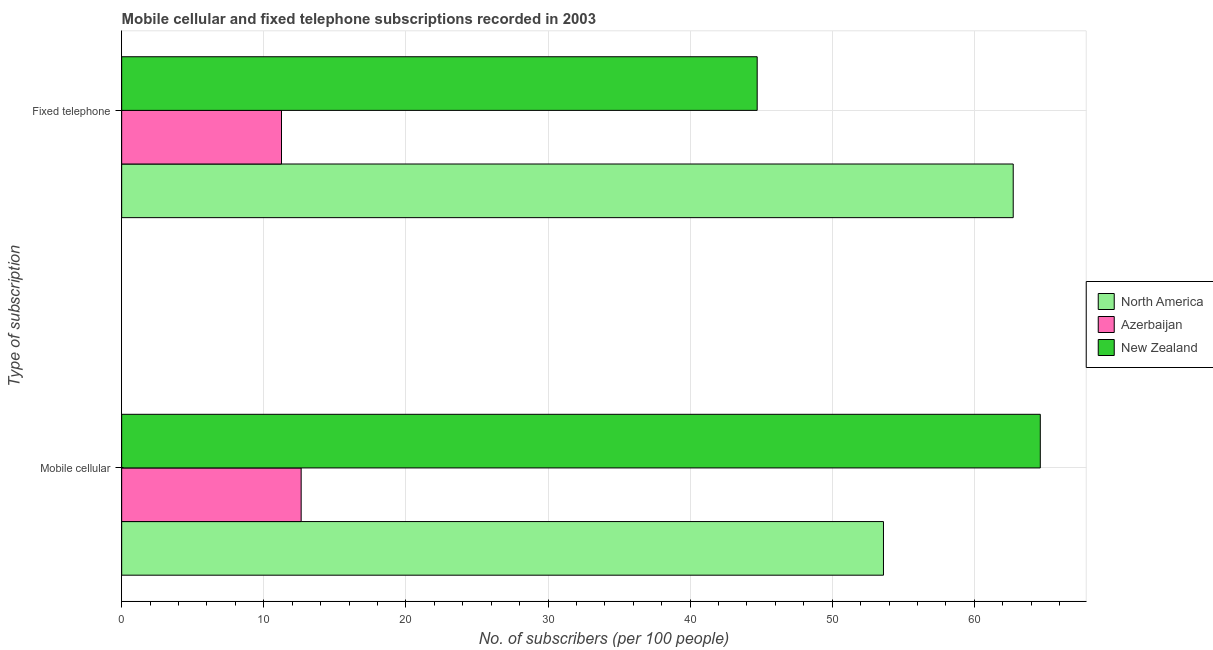How many groups of bars are there?
Your response must be concise. 2. Are the number of bars per tick equal to the number of legend labels?
Provide a succinct answer. Yes. How many bars are there on the 1st tick from the top?
Keep it short and to the point. 3. How many bars are there on the 1st tick from the bottom?
Make the answer very short. 3. What is the label of the 1st group of bars from the top?
Ensure brevity in your answer.  Fixed telephone. What is the number of fixed telephone subscribers in Azerbaijan?
Provide a succinct answer. 11.25. Across all countries, what is the maximum number of fixed telephone subscribers?
Offer a very short reply. 62.74. Across all countries, what is the minimum number of fixed telephone subscribers?
Offer a very short reply. 11.25. In which country was the number of mobile cellular subscribers maximum?
Your answer should be very brief. New Zealand. In which country was the number of fixed telephone subscribers minimum?
Your response must be concise. Azerbaijan. What is the total number of fixed telephone subscribers in the graph?
Provide a short and direct response. 118.7. What is the difference between the number of fixed telephone subscribers in North America and that in New Zealand?
Your answer should be very brief. 18.02. What is the difference between the number of mobile cellular subscribers in New Zealand and the number of fixed telephone subscribers in North America?
Keep it short and to the point. 1.91. What is the average number of fixed telephone subscribers per country?
Your response must be concise. 39.57. What is the difference between the number of fixed telephone subscribers and number of mobile cellular subscribers in North America?
Your answer should be very brief. 9.13. In how many countries, is the number of mobile cellular subscribers greater than 20 ?
Your answer should be compact. 2. What is the ratio of the number of mobile cellular subscribers in North America to that in New Zealand?
Keep it short and to the point. 0.83. Is the number of mobile cellular subscribers in New Zealand less than that in Azerbaijan?
Your answer should be very brief. No. What does the 3rd bar from the bottom in Fixed telephone represents?
Keep it short and to the point. New Zealand. Are all the bars in the graph horizontal?
Your answer should be compact. Yes. Are the values on the major ticks of X-axis written in scientific E-notation?
Make the answer very short. No. Does the graph contain any zero values?
Provide a short and direct response. No. Does the graph contain grids?
Your answer should be very brief. Yes. Where does the legend appear in the graph?
Your answer should be very brief. Center right. How are the legend labels stacked?
Provide a succinct answer. Vertical. What is the title of the graph?
Your response must be concise. Mobile cellular and fixed telephone subscriptions recorded in 2003. What is the label or title of the X-axis?
Your answer should be very brief. No. of subscribers (per 100 people). What is the label or title of the Y-axis?
Offer a very short reply. Type of subscription. What is the No. of subscribers (per 100 people) in North America in Mobile cellular?
Your response must be concise. 53.6. What is the No. of subscribers (per 100 people) of Azerbaijan in Mobile cellular?
Your answer should be very brief. 12.63. What is the No. of subscribers (per 100 people) of New Zealand in Mobile cellular?
Make the answer very short. 64.64. What is the No. of subscribers (per 100 people) in North America in Fixed telephone?
Offer a terse response. 62.74. What is the No. of subscribers (per 100 people) in Azerbaijan in Fixed telephone?
Offer a terse response. 11.25. What is the No. of subscribers (per 100 people) of New Zealand in Fixed telephone?
Provide a short and direct response. 44.72. Across all Type of subscription, what is the maximum No. of subscribers (per 100 people) in North America?
Keep it short and to the point. 62.74. Across all Type of subscription, what is the maximum No. of subscribers (per 100 people) in Azerbaijan?
Your answer should be compact. 12.63. Across all Type of subscription, what is the maximum No. of subscribers (per 100 people) of New Zealand?
Give a very brief answer. 64.64. Across all Type of subscription, what is the minimum No. of subscribers (per 100 people) in North America?
Provide a short and direct response. 53.6. Across all Type of subscription, what is the minimum No. of subscribers (per 100 people) of Azerbaijan?
Offer a very short reply. 11.25. Across all Type of subscription, what is the minimum No. of subscribers (per 100 people) in New Zealand?
Your answer should be compact. 44.72. What is the total No. of subscribers (per 100 people) of North America in the graph?
Make the answer very short. 116.34. What is the total No. of subscribers (per 100 people) of Azerbaijan in the graph?
Make the answer very short. 23.88. What is the total No. of subscribers (per 100 people) of New Zealand in the graph?
Provide a succinct answer. 109.36. What is the difference between the No. of subscribers (per 100 people) of North America in Mobile cellular and that in Fixed telephone?
Make the answer very short. -9.13. What is the difference between the No. of subscribers (per 100 people) in Azerbaijan in Mobile cellular and that in Fixed telephone?
Ensure brevity in your answer.  1.38. What is the difference between the No. of subscribers (per 100 people) in New Zealand in Mobile cellular and that in Fixed telephone?
Your answer should be compact. 19.92. What is the difference between the No. of subscribers (per 100 people) in North America in Mobile cellular and the No. of subscribers (per 100 people) in Azerbaijan in Fixed telephone?
Ensure brevity in your answer.  42.36. What is the difference between the No. of subscribers (per 100 people) in North America in Mobile cellular and the No. of subscribers (per 100 people) in New Zealand in Fixed telephone?
Make the answer very short. 8.89. What is the difference between the No. of subscribers (per 100 people) of Azerbaijan in Mobile cellular and the No. of subscribers (per 100 people) of New Zealand in Fixed telephone?
Your response must be concise. -32.09. What is the average No. of subscribers (per 100 people) of North America per Type of subscription?
Your response must be concise. 58.17. What is the average No. of subscribers (per 100 people) of Azerbaijan per Type of subscription?
Offer a terse response. 11.94. What is the average No. of subscribers (per 100 people) of New Zealand per Type of subscription?
Your answer should be very brief. 54.68. What is the difference between the No. of subscribers (per 100 people) of North America and No. of subscribers (per 100 people) of Azerbaijan in Mobile cellular?
Offer a very short reply. 40.98. What is the difference between the No. of subscribers (per 100 people) of North America and No. of subscribers (per 100 people) of New Zealand in Mobile cellular?
Your answer should be compact. -11.04. What is the difference between the No. of subscribers (per 100 people) in Azerbaijan and No. of subscribers (per 100 people) in New Zealand in Mobile cellular?
Make the answer very short. -52.01. What is the difference between the No. of subscribers (per 100 people) of North America and No. of subscribers (per 100 people) of Azerbaijan in Fixed telephone?
Provide a succinct answer. 51.49. What is the difference between the No. of subscribers (per 100 people) of North America and No. of subscribers (per 100 people) of New Zealand in Fixed telephone?
Provide a succinct answer. 18.02. What is the difference between the No. of subscribers (per 100 people) of Azerbaijan and No. of subscribers (per 100 people) of New Zealand in Fixed telephone?
Your response must be concise. -33.47. What is the ratio of the No. of subscribers (per 100 people) in North America in Mobile cellular to that in Fixed telephone?
Make the answer very short. 0.85. What is the ratio of the No. of subscribers (per 100 people) in Azerbaijan in Mobile cellular to that in Fixed telephone?
Provide a succinct answer. 1.12. What is the ratio of the No. of subscribers (per 100 people) in New Zealand in Mobile cellular to that in Fixed telephone?
Provide a succinct answer. 1.45. What is the difference between the highest and the second highest No. of subscribers (per 100 people) of North America?
Your answer should be very brief. 9.13. What is the difference between the highest and the second highest No. of subscribers (per 100 people) in Azerbaijan?
Offer a terse response. 1.38. What is the difference between the highest and the second highest No. of subscribers (per 100 people) in New Zealand?
Offer a terse response. 19.92. What is the difference between the highest and the lowest No. of subscribers (per 100 people) of North America?
Your response must be concise. 9.13. What is the difference between the highest and the lowest No. of subscribers (per 100 people) in Azerbaijan?
Your answer should be compact. 1.38. What is the difference between the highest and the lowest No. of subscribers (per 100 people) of New Zealand?
Ensure brevity in your answer.  19.92. 